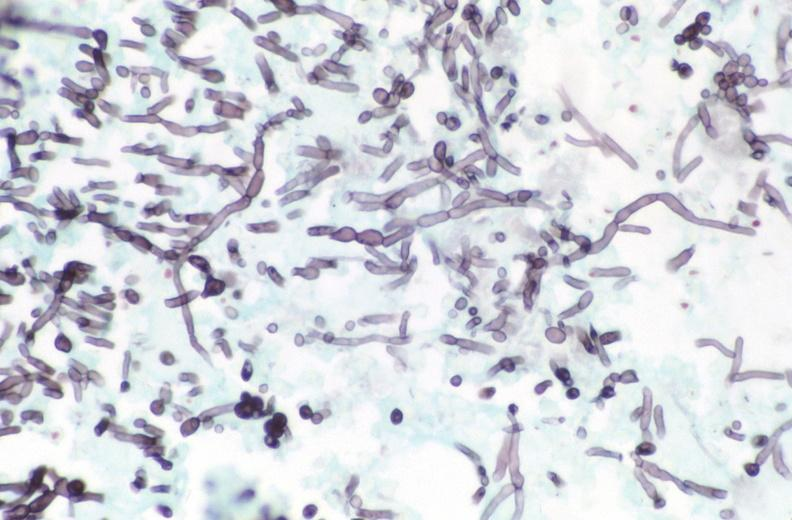s marked present?
Answer the question using a single word or phrase. No 